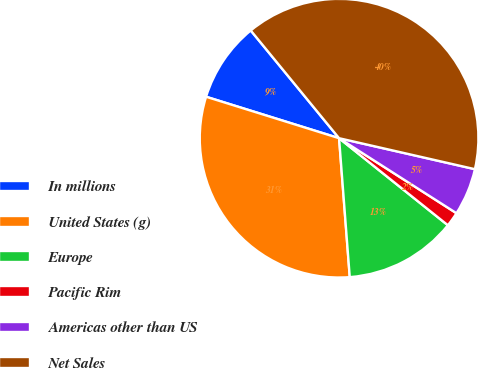Convert chart to OTSL. <chart><loc_0><loc_0><loc_500><loc_500><pie_chart><fcel>In millions<fcel>United States (g)<fcel>Europe<fcel>Pacific Rim<fcel>Americas other than US<fcel>Net Sales<nl><fcel>9.26%<fcel>31.03%<fcel>13.04%<fcel>1.69%<fcel>5.48%<fcel>39.5%<nl></chart> 